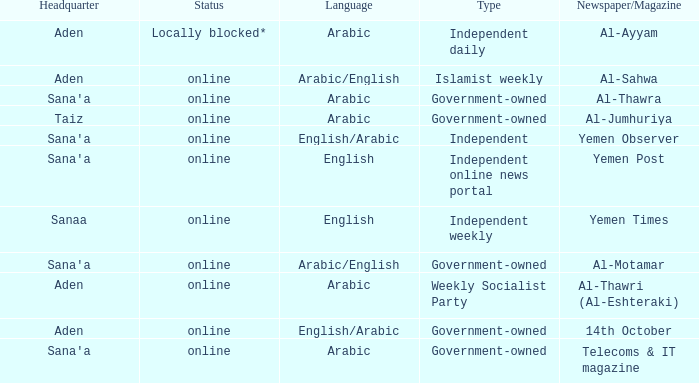What is Headquarter, when Language is English, and when Type is Independent Online News Portal? Sana'a. 